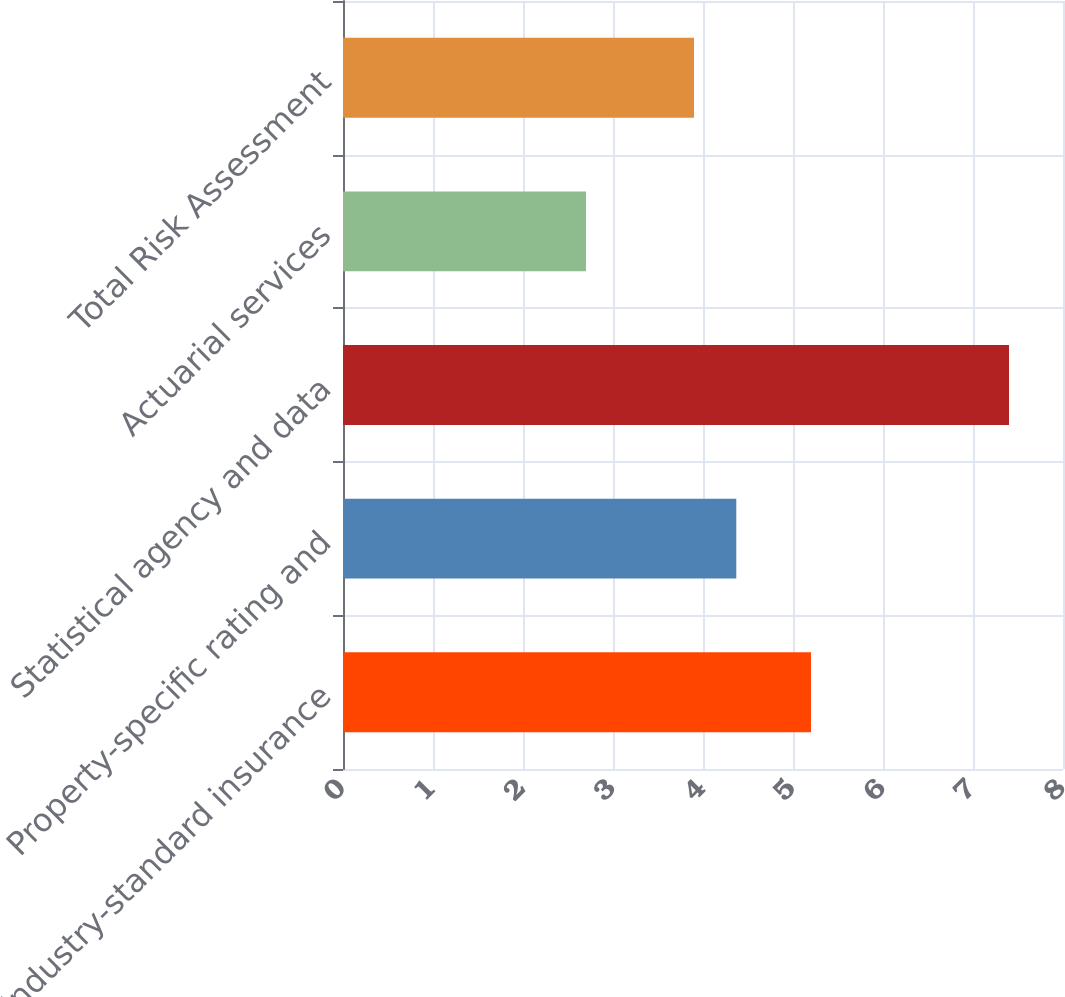Convert chart. <chart><loc_0><loc_0><loc_500><loc_500><bar_chart><fcel>Industry-standard insurance<fcel>Property-specific rating and<fcel>Statistical agency and data<fcel>Actuarial services<fcel>Total Risk Assessment<nl><fcel>5.2<fcel>4.37<fcel>7.4<fcel>2.7<fcel>3.9<nl></chart> 